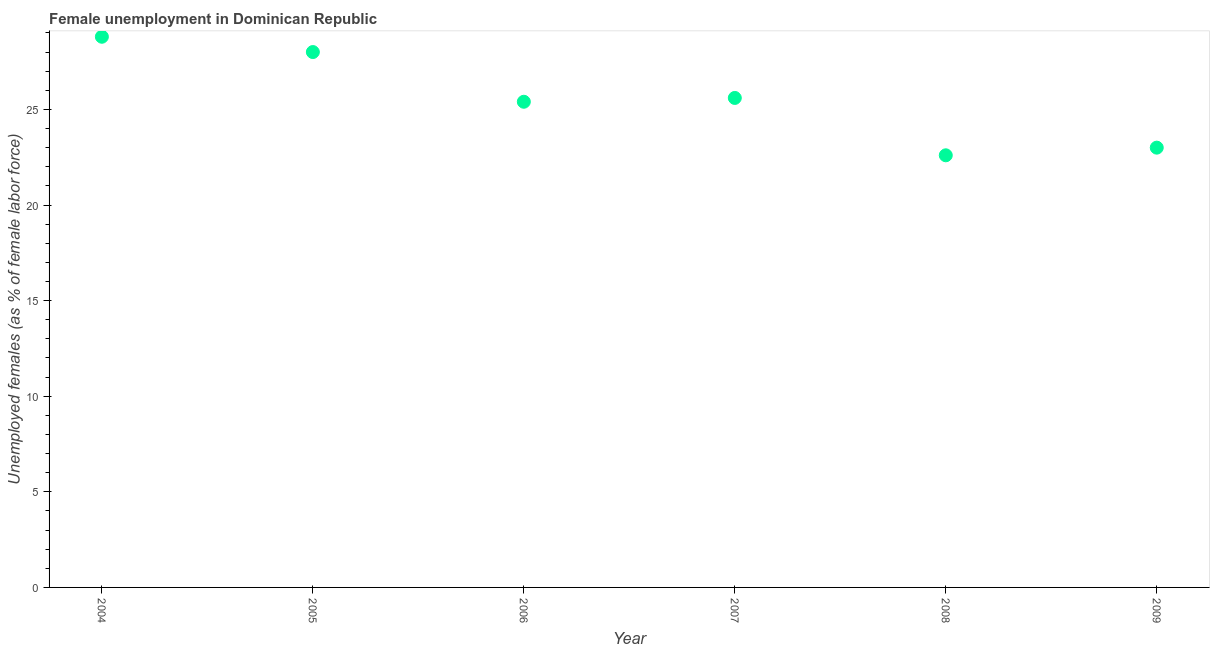What is the unemployed females population in 2007?
Offer a very short reply. 25.6. Across all years, what is the maximum unemployed females population?
Your response must be concise. 28.8. Across all years, what is the minimum unemployed females population?
Provide a short and direct response. 22.6. In which year was the unemployed females population maximum?
Your response must be concise. 2004. What is the sum of the unemployed females population?
Your answer should be very brief. 153.4. What is the difference between the unemployed females population in 2006 and 2008?
Your answer should be very brief. 2.8. What is the average unemployed females population per year?
Provide a short and direct response. 25.57. What is the median unemployed females population?
Keep it short and to the point. 25.5. Do a majority of the years between 2009 and 2008 (inclusive) have unemployed females population greater than 8 %?
Ensure brevity in your answer.  No. What is the ratio of the unemployed females population in 2004 to that in 2007?
Offer a terse response. 1.12. Is the unemployed females population in 2005 less than that in 2006?
Your answer should be very brief. No. What is the difference between the highest and the second highest unemployed females population?
Give a very brief answer. 0.8. Is the sum of the unemployed females population in 2004 and 2009 greater than the maximum unemployed females population across all years?
Keep it short and to the point. Yes. What is the difference between the highest and the lowest unemployed females population?
Keep it short and to the point. 6.2. How many dotlines are there?
Keep it short and to the point. 1. How many years are there in the graph?
Your answer should be compact. 6. What is the title of the graph?
Keep it short and to the point. Female unemployment in Dominican Republic. What is the label or title of the X-axis?
Ensure brevity in your answer.  Year. What is the label or title of the Y-axis?
Offer a terse response. Unemployed females (as % of female labor force). What is the Unemployed females (as % of female labor force) in 2004?
Make the answer very short. 28.8. What is the Unemployed females (as % of female labor force) in 2005?
Offer a terse response. 28. What is the Unemployed females (as % of female labor force) in 2006?
Give a very brief answer. 25.4. What is the Unemployed females (as % of female labor force) in 2007?
Offer a terse response. 25.6. What is the Unemployed females (as % of female labor force) in 2008?
Give a very brief answer. 22.6. What is the difference between the Unemployed females (as % of female labor force) in 2004 and 2006?
Your answer should be very brief. 3.4. What is the difference between the Unemployed females (as % of female labor force) in 2004 and 2007?
Provide a succinct answer. 3.2. What is the difference between the Unemployed females (as % of female labor force) in 2004 and 2008?
Give a very brief answer. 6.2. What is the difference between the Unemployed females (as % of female labor force) in 2005 and 2008?
Keep it short and to the point. 5.4. What is the difference between the Unemployed females (as % of female labor force) in 2005 and 2009?
Offer a very short reply. 5. What is the difference between the Unemployed females (as % of female labor force) in 2006 and 2009?
Your response must be concise. 2.4. What is the difference between the Unemployed females (as % of female labor force) in 2007 and 2008?
Offer a terse response. 3. What is the difference between the Unemployed females (as % of female labor force) in 2007 and 2009?
Offer a very short reply. 2.6. What is the ratio of the Unemployed females (as % of female labor force) in 2004 to that in 2005?
Offer a terse response. 1.03. What is the ratio of the Unemployed females (as % of female labor force) in 2004 to that in 2006?
Give a very brief answer. 1.13. What is the ratio of the Unemployed females (as % of female labor force) in 2004 to that in 2007?
Your answer should be compact. 1.12. What is the ratio of the Unemployed females (as % of female labor force) in 2004 to that in 2008?
Your response must be concise. 1.27. What is the ratio of the Unemployed females (as % of female labor force) in 2004 to that in 2009?
Provide a succinct answer. 1.25. What is the ratio of the Unemployed females (as % of female labor force) in 2005 to that in 2006?
Ensure brevity in your answer.  1.1. What is the ratio of the Unemployed females (as % of female labor force) in 2005 to that in 2007?
Give a very brief answer. 1.09. What is the ratio of the Unemployed females (as % of female labor force) in 2005 to that in 2008?
Your answer should be compact. 1.24. What is the ratio of the Unemployed females (as % of female labor force) in 2005 to that in 2009?
Your answer should be compact. 1.22. What is the ratio of the Unemployed females (as % of female labor force) in 2006 to that in 2008?
Offer a terse response. 1.12. What is the ratio of the Unemployed females (as % of female labor force) in 2006 to that in 2009?
Your answer should be very brief. 1.1. What is the ratio of the Unemployed females (as % of female labor force) in 2007 to that in 2008?
Provide a succinct answer. 1.13. What is the ratio of the Unemployed females (as % of female labor force) in 2007 to that in 2009?
Ensure brevity in your answer.  1.11. What is the ratio of the Unemployed females (as % of female labor force) in 2008 to that in 2009?
Give a very brief answer. 0.98. 